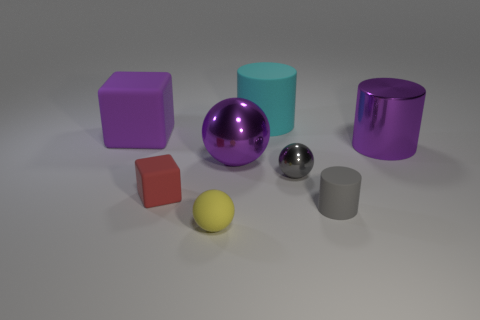Add 2 big yellow rubber spheres. How many objects exist? 10 Subtract all blocks. How many objects are left? 6 Subtract all cyan cylinders. Subtract all rubber things. How many objects are left? 2 Add 2 matte balls. How many matte balls are left? 3 Add 7 big matte cubes. How many big matte cubes exist? 8 Subtract 0 blue spheres. How many objects are left? 8 